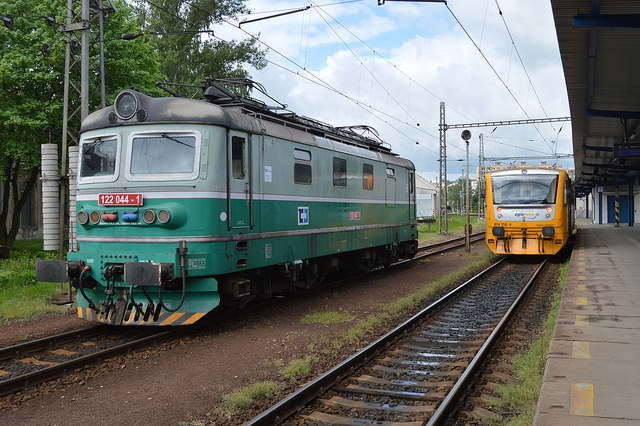Describe the objects in this image and their specific colors. I can see train in darkgreen, black, gray, darkgray, and teal tones and train in darkgreen, black, darkgray, orange, and olive tones in this image. 